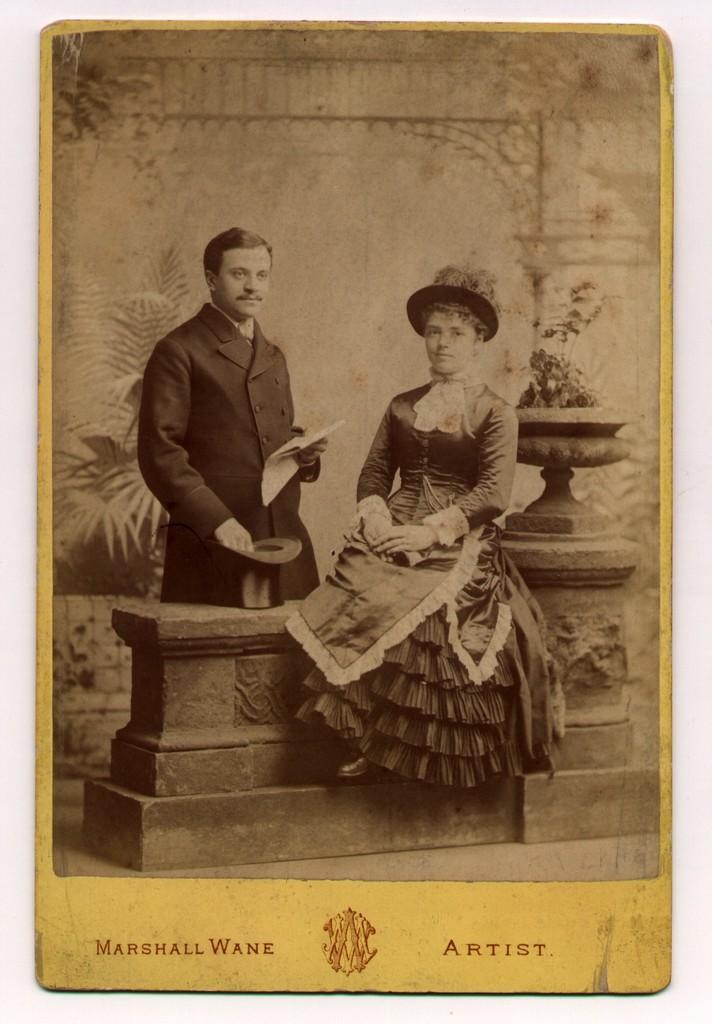Please provide a concise description of this image. This picture might be a painting on the book and it is a black and white image. In this image, we can see a woman is sitting on the bench and a man is standing in front of the bench holding and cap in his hand. In the background, we can see some plants, flower pot. 